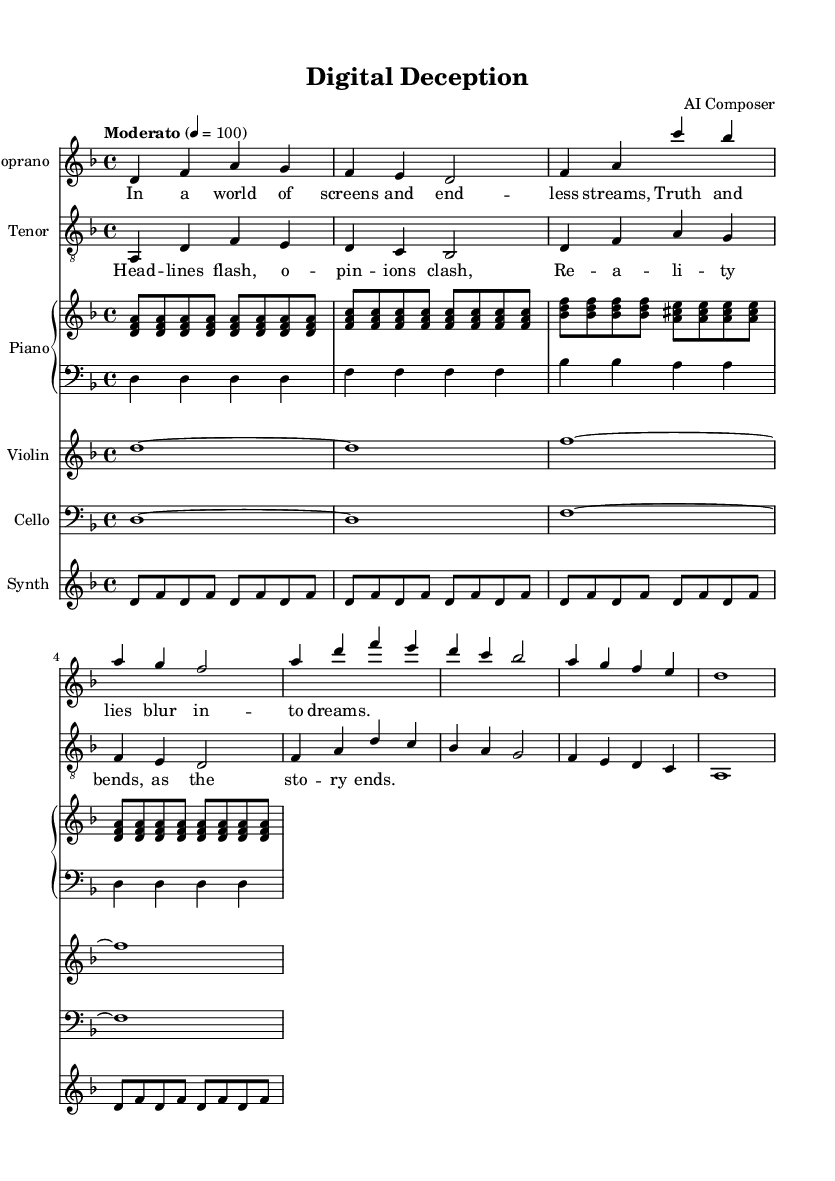What is the key signature of this music? The key signature is indicated by the number of sharps or flats at the beginning of the staff. In this case, D minor is indicated, which has one flat.
Answer: D minor What is the time signature of this music? The time signature is denoted at the beginning of the score, shown as a fraction. Here, 4/4 is presented, indicating there are four beats in each measure.
Answer: 4/4 What is the tempo marking for this piece? The tempo is noted in Italian terms or descriptive words, indicating the speed. In this score, "Moderato" is mentioned, which specifies a moderate tempo.
Answer: Moderato How many measures are in the Soprano part? To find the number of measures, we count the staff lines and bars in the Soprano part. There are a total of 8 measures in the Soprano part.
Answer: 8 What are the lyrics of the tenor in the first section? The lyrics are placed under the notes in the score. The first section of the Tenor part contains the words: "Head lines flash, opinions clash."
Answer: Head lines flash, opinions clash What is the instrumentation used in this opera? The instrumentation is typically listed at the beginning; observing the score reveals the inclusion of Soprano, Tenor, Piano (right and left hand), Violin, Cello, and Synth.
Answer: Soprano, Tenor, Piano, Violin, Cello, Synth How does the musical texture change in the opera piece? By analyzing how the parts interact, we see that the textures vary from solo vocal lines to moments where the instrumental parts support the voices, creating a richer and varied texture throughout the piece.
Answer: Varied texture 